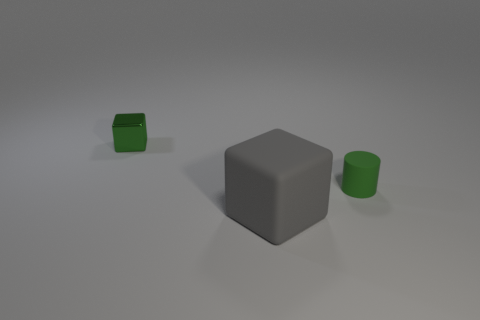What kind of environment or setting could this image represent? This image has a minimalist aesthetic, reminiscent of a controlled environment like a studio setup. The even lighting and soft shadows suggest either a virtual simulation or a physical studio with diffused lighting. The plain background and absence of additional context let the viewer project their own interpretation, making it suitable for a conceptual representation in areas such as design, mathematics, or even philosophy. 